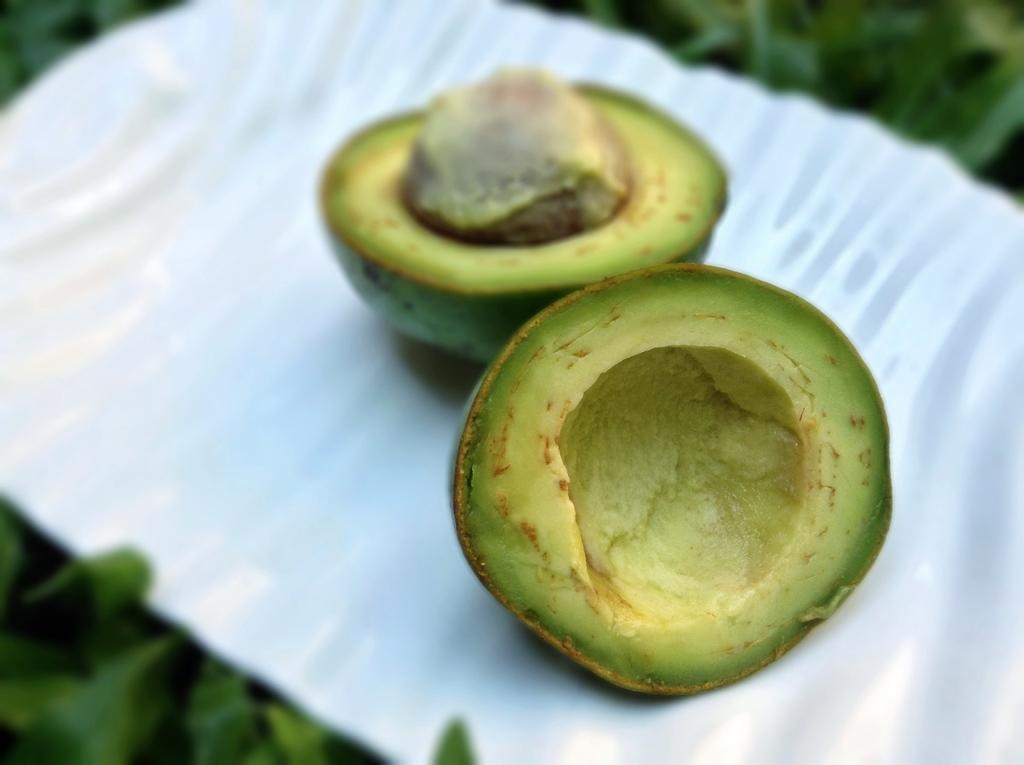In one or two sentences, can you explain what this image depicts? In this image there is a fruit on an object that looks like a plate, at the background of the image there is a plant. 